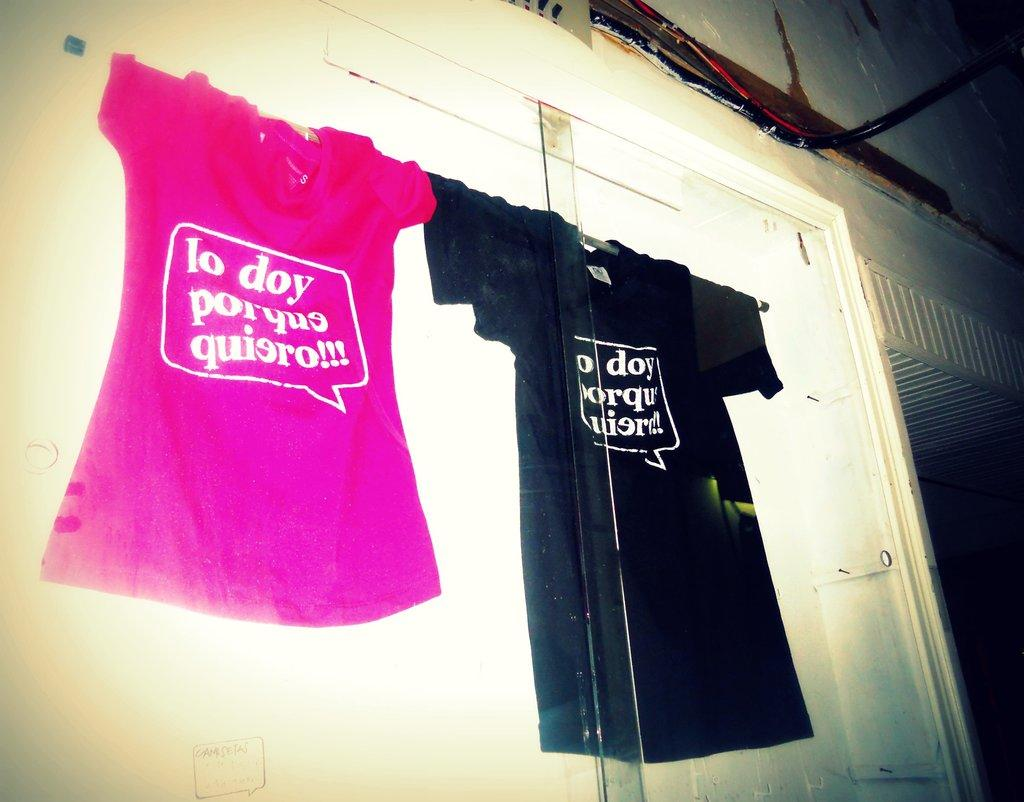<image>
Summarize the visual content of the image. a pink and a black t shirt hanging together, one of which has lo doy porquo quiero written on it 